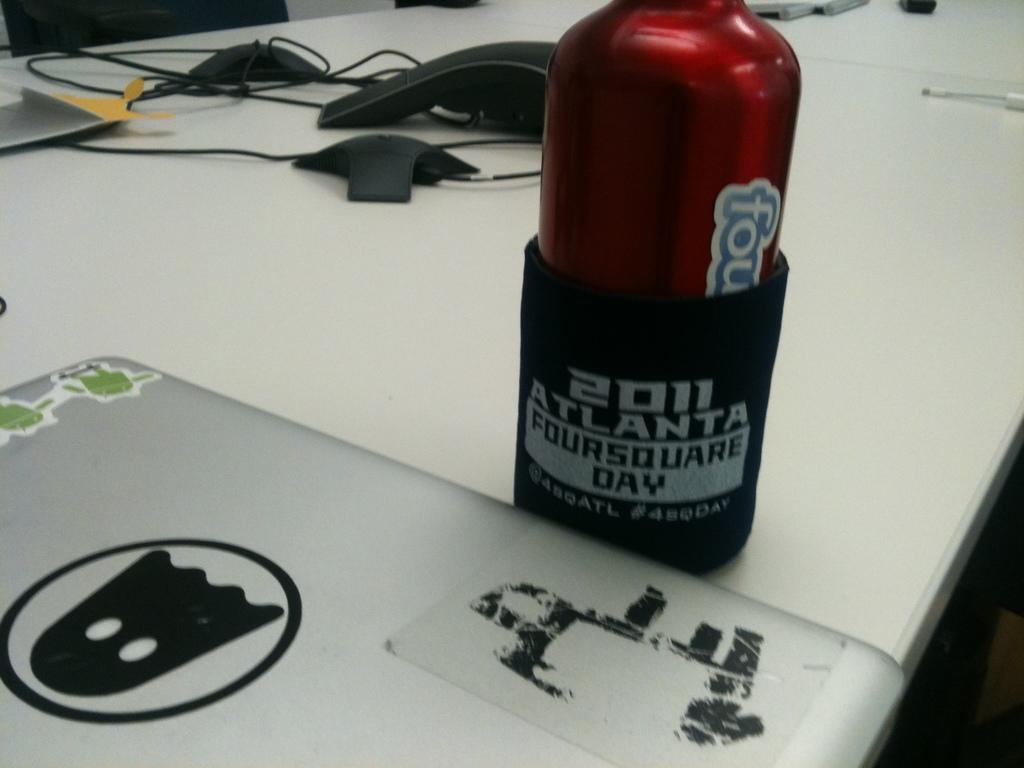What piece of furniture is present in the image? There is a table in the image. What object is placed on the table? There is a bottle on the table. What is inside the bottle? The bottle contains a pouch. What electronic device is on the table? There is a laptop on the table. What type of items can be seen on the table besides the laptop? There are different types of wires on the table. What type of dress is the laptop wearing in the image? The laptop is not wearing a dress, as it is an electronic device and not a person. 